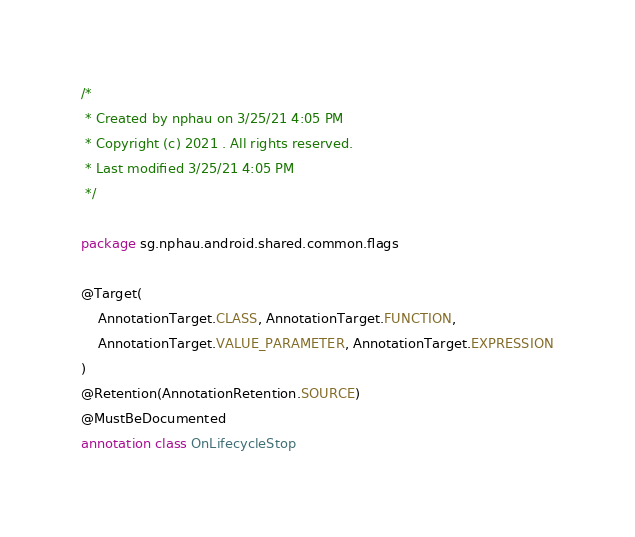<code> <loc_0><loc_0><loc_500><loc_500><_Kotlin_>/*
 * Created by nphau on 3/25/21 4:05 PM
 * Copyright (c) 2021 . All rights reserved.
 * Last modified 3/25/21 4:05 PM
 */

package sg.nphau.android.shared.common.flags

@Target(
    AnnotationTarget.CLASS, AnnotationTarget.FUNCTION,
    AnnotationTarget.VALUE_PARAMETER, AnnotationTarget.EXPRESSION
)
@Retention(AnnotationRetention.SOURCE)
@MustBeDocumented
annotation class OnLifecycleStop</code> 